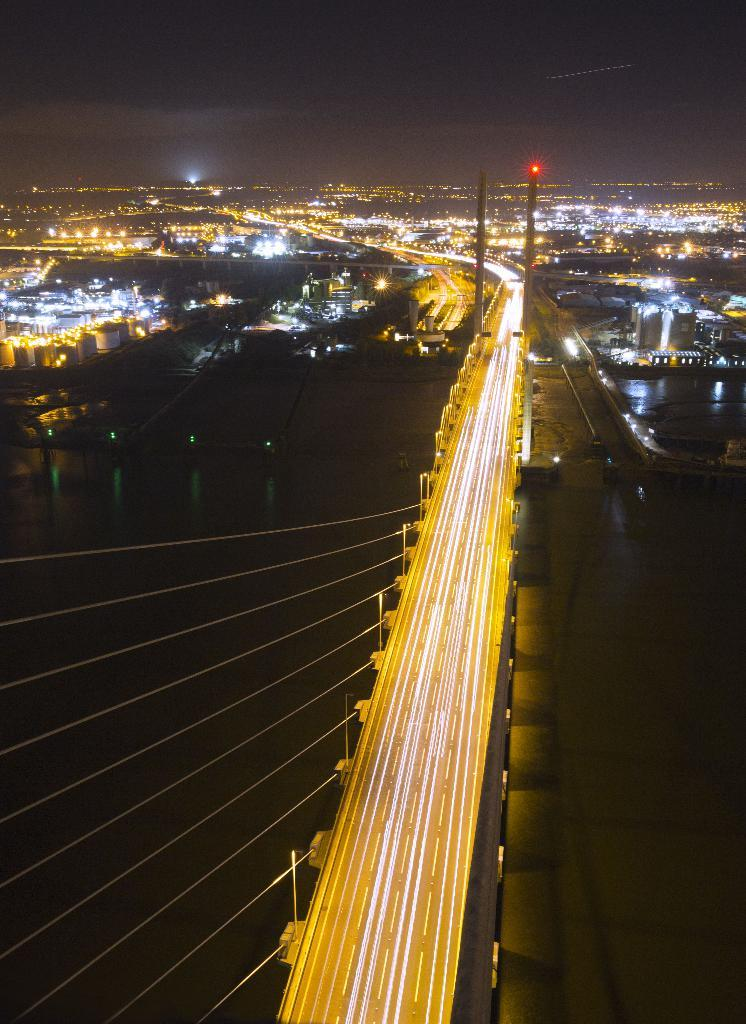What type of structures can be seen in the image? There are lights, a bridge, and poles in the image. What is the natural element visible in the image? The sky is visible in the image. Can you describe the bridge in the image? The image shows a bridge, but no specific details about its design or construction are provided. What type of pie is being served on the bridge in the image? There is no pie present in the image; it features lights, a bridge, and poles. What rate is the mountain moving in the image? There is no mountain present in the image, and therefore no movement or rate can be observed. 